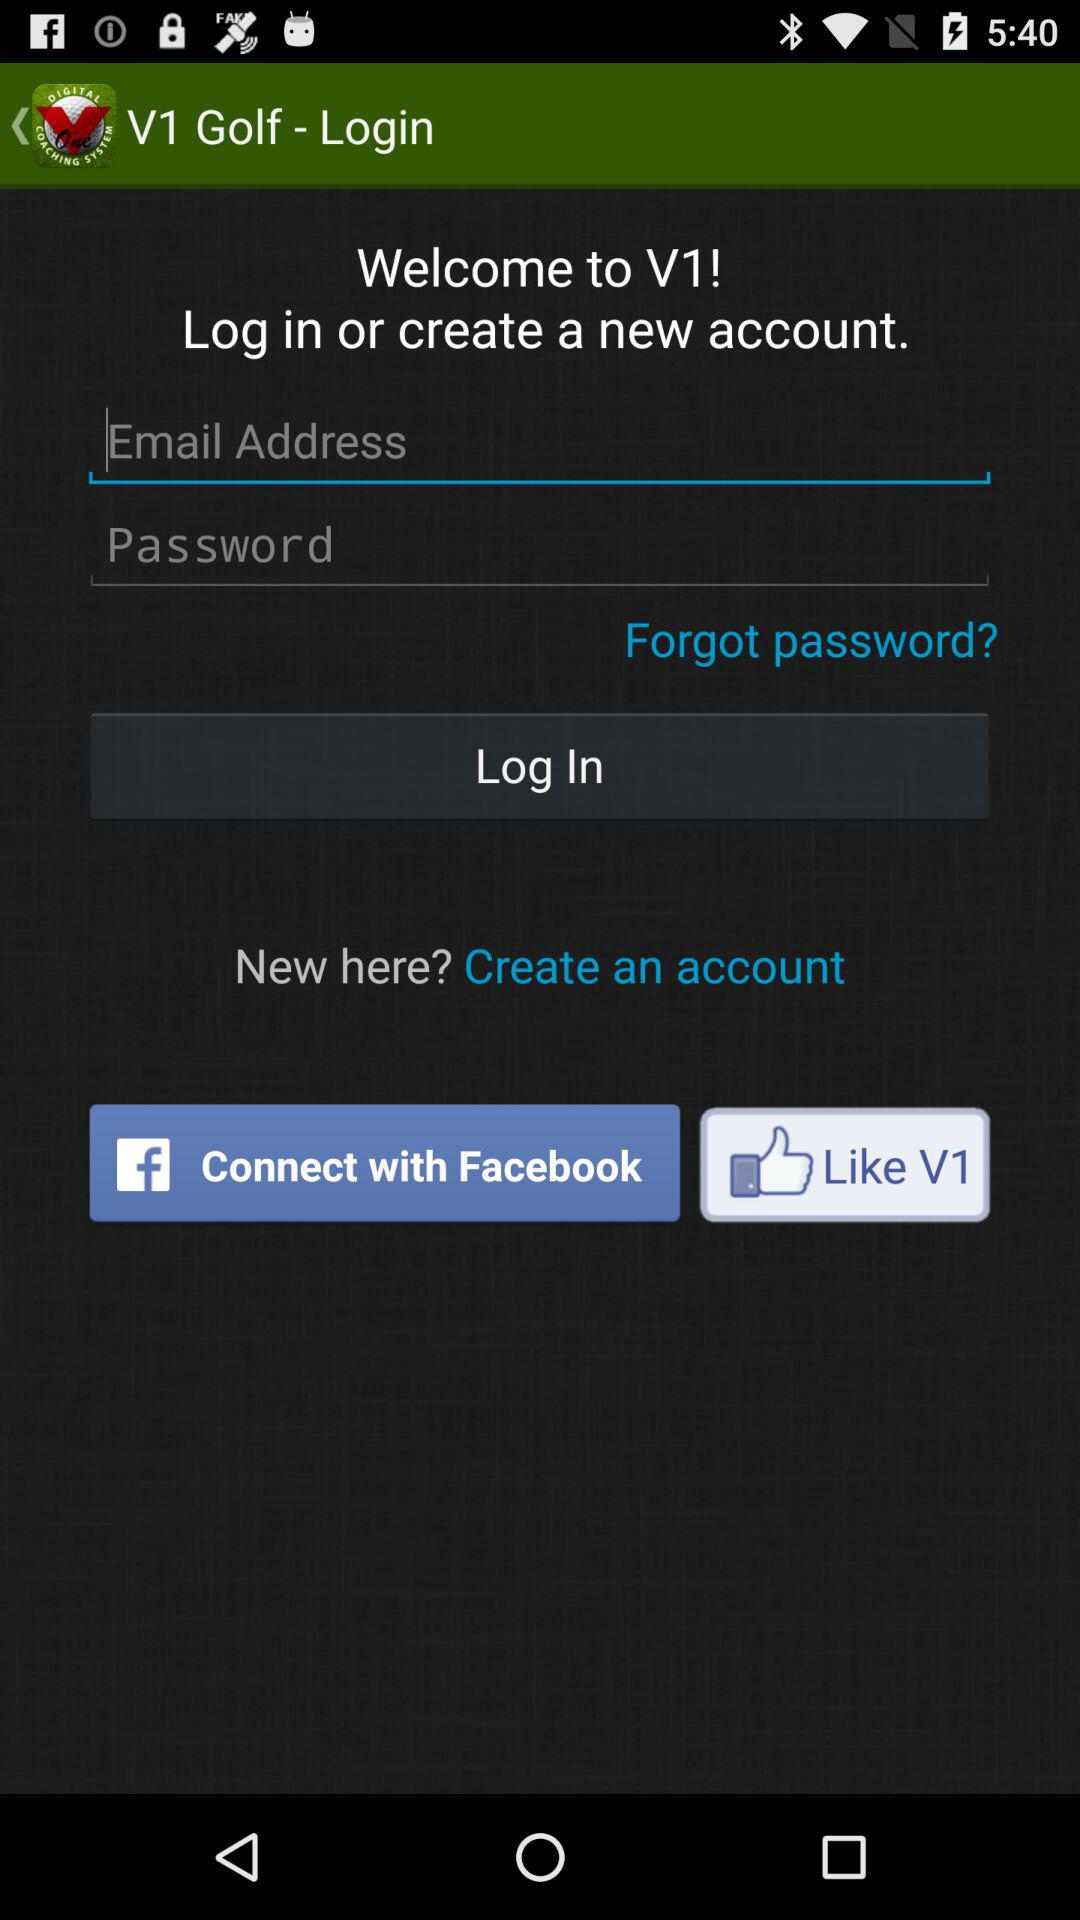Through what application can the user log in? The user can log in through "Facebook". 